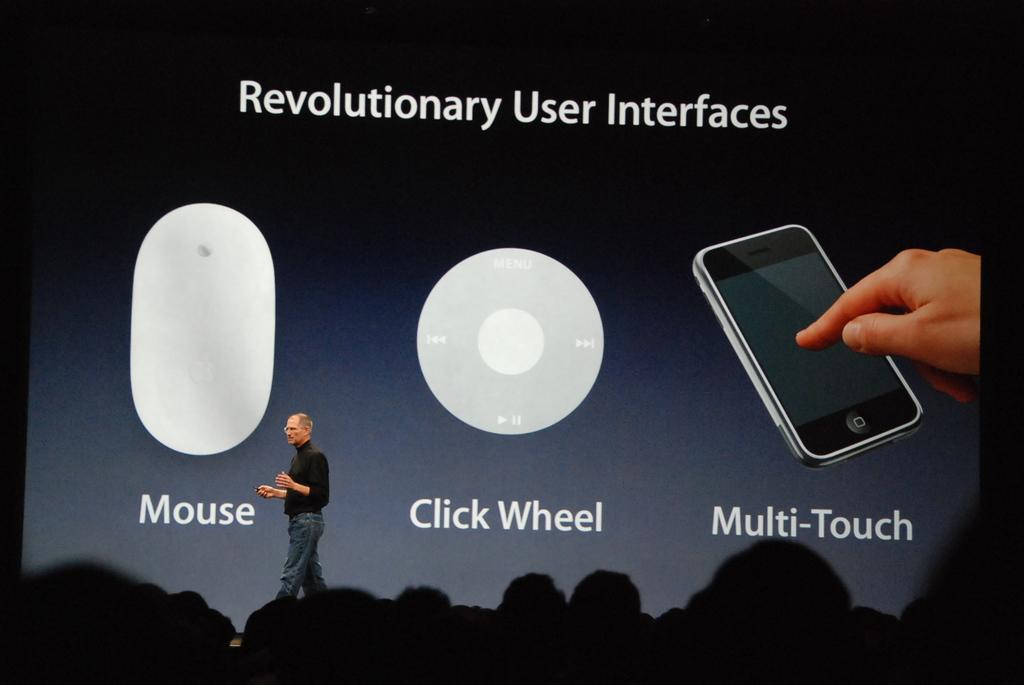<image>
Write a terse but informative summary of the picture. Shows the mouse or click wheel part of a multi touch phone. 